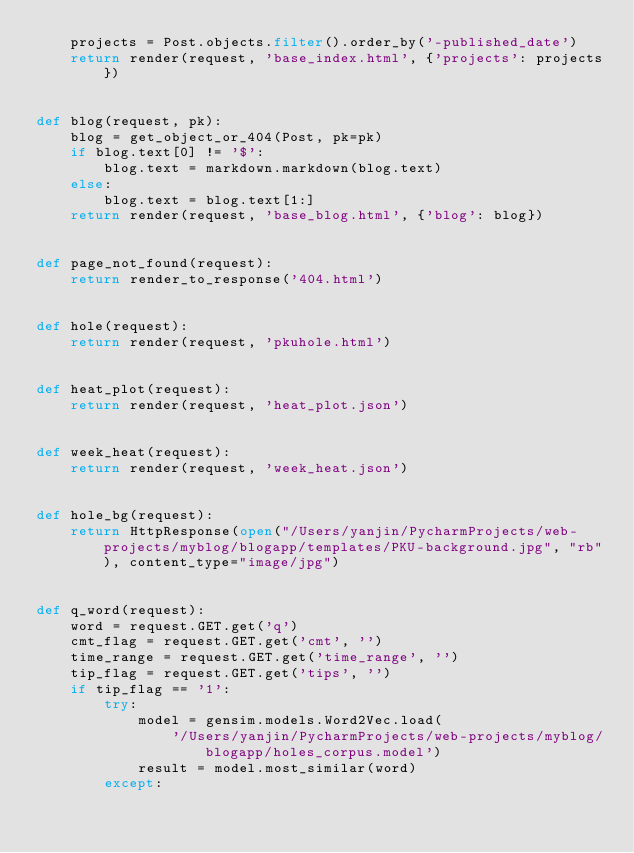Convert code to text. <code><loc_0><loc_0><loc_500><loc_500><_Python_>    projects = Post.objects.filter().order_by('-published_date')
    return render(request, 'base_index.html', {'projects': projects})


def blog(request, pk):
    blog = get_object_or_404(Post, pk=pk)
    if blog.text[0] != '$':
        blog.text = markdown.markdown(blog.text)
    else:
        blog.text = blog.text[1:]
    return render(request, 'base_blog.html', {'blog': blog})


def page_not_found(request):
    return render_to_response('404.html')


def hole(request):
    return render(request, 'pkuhole.html')


def heat_plot(request):
    return render(request, 'heat_plot.json')


def week_heat(request):
    return render(request, 'week_heat.json')


def hole_bg(request):
    return HttpResponse(open("/Users/yanjin/PycharmProjects/web-projects/myblog/blogapp/templates/PKU-background.jpg", "rb"), content_type="image/jpg")


def q_word(request):
    word = request.GET.get('q')
    cmt_flag = request.GET.get('cmt', '')
    time_range = request.GET.get('time_range', '')
    tip_flag = request.GET.get('tips', '')
    if tip_flag == '1':
        try:
            model = gensim.models.Word2Vec.load(
                '/Users/yanjin/PycharmProjects/web-projects/myblog/blogapp/holes_corpus.model')
            result = model.most_similar(word)
        except:</code> 